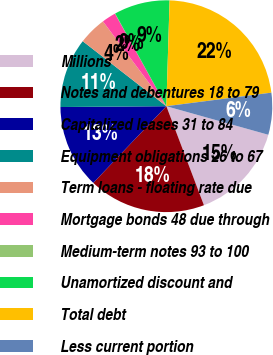Convert chart. <chart><loc_0><loc_0><loc_500><loc_500><pie_chart><fcel>Millions<fcel>Notes and debentures 18 to 79<fcel>Capitalized leases 31 to 84<fcel>Equipment obligations 26 to 67<fcel>Term loans - floating rate due<fcel>Mortgage bonds 48 due through<fcel>Medium-term notes 93 to 100<fcel>Unamortized discount and<fcel>Total debt<fcel>Less current portion<nl><fcel>14.88%<fcel>17.89%<fcel>12.76%<fcel>10.64%<fcel>4.27%<fcel>2.15%<fcel>0.03%<fcel>8.52%<fcel>22.47%<fcel>6.39%<nl></chart> 